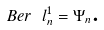<formula> <loc_0><loc_0><loc_500><loc_500>B e r \text { } l _ { n } ^ { 1 } = \Psi _ { n } \text {.}</formula> 